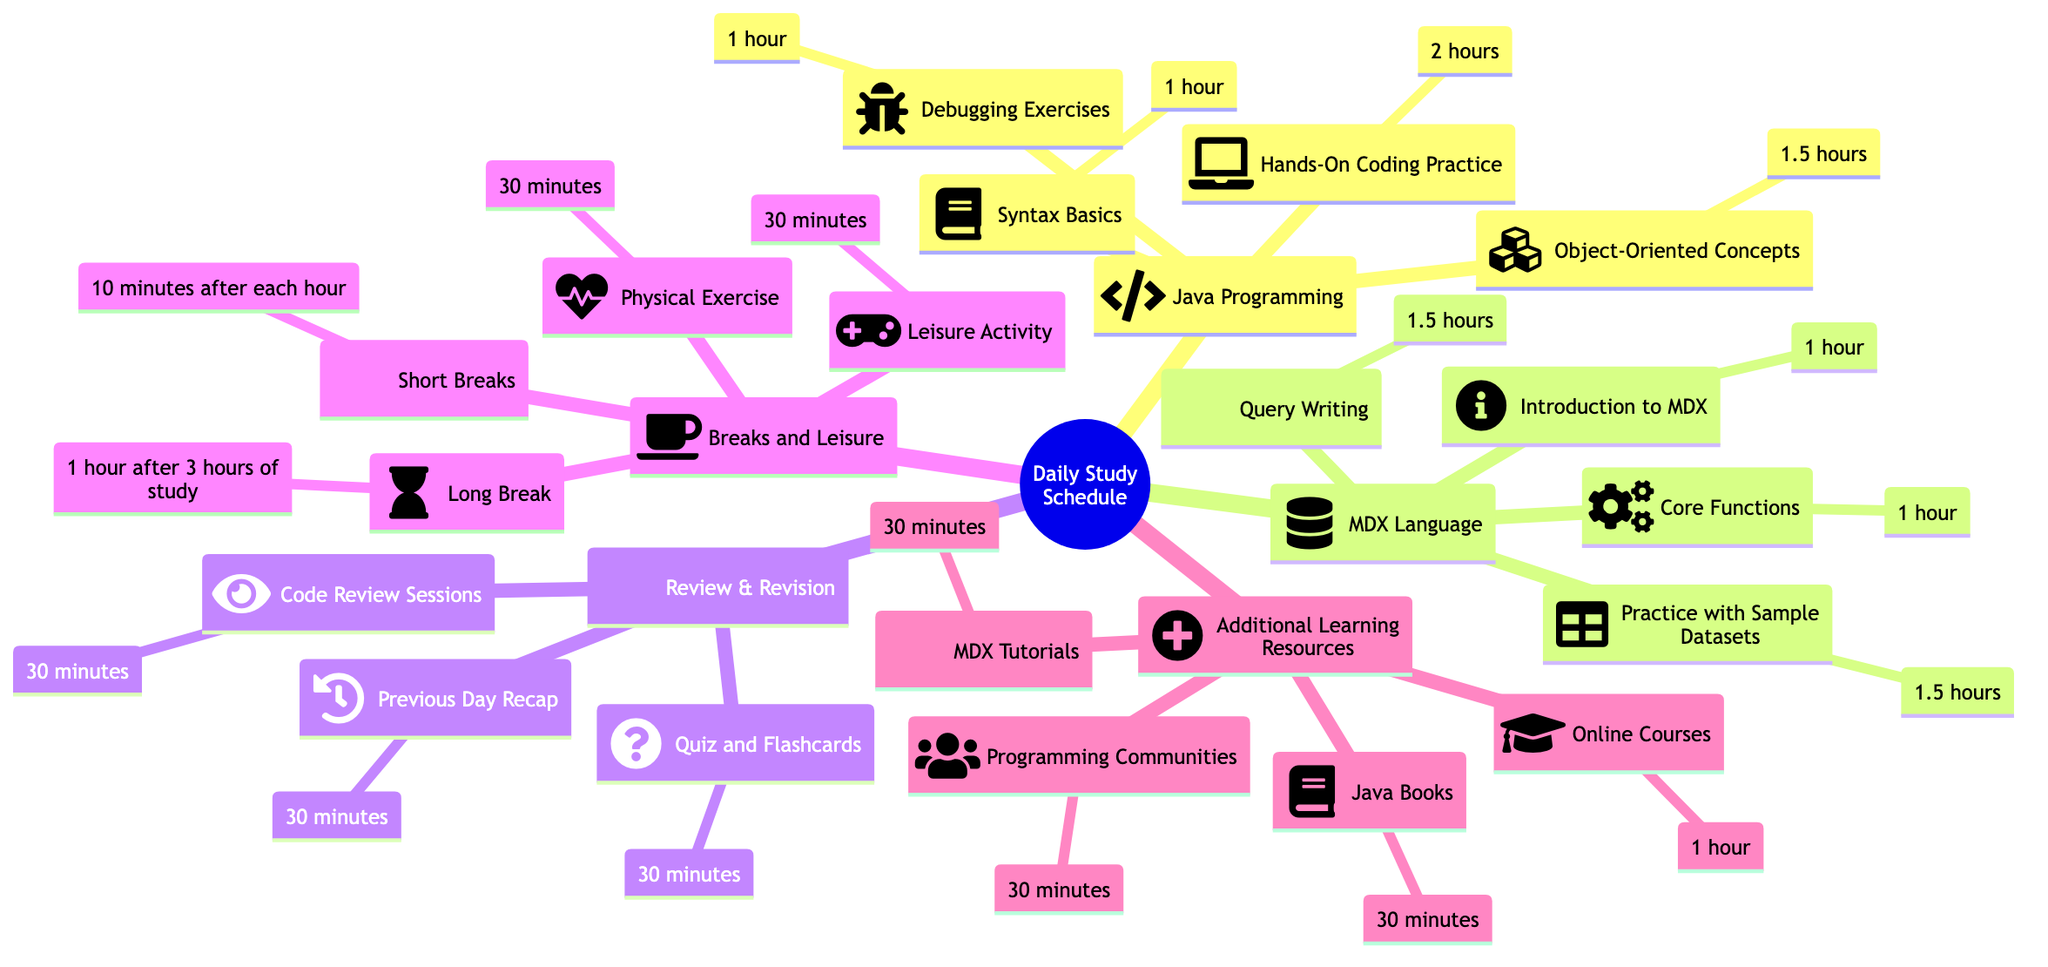What is the total time allocated for Java Programming study? To find the total time for Java Programming, I need to sum the durations of all the sub-nodes: 1 hour (Syntax Basics) + 1.5 hours (Object-Oriented Concepts) + 2 hours (Hands-On Coding Practice) + 1 hour (Debugging Exercises) = 5.5 hours.
Answer: 5.5 hours How many subjects are covered in the daily study schedule? Counting the main categories in the diagram, I see five: Java Programming, MDX Language, Review & Revision, Breaks and Leisure, and Additional Learning Resources. Thus, the total is 5.
Answer: 5 What is the duration of Core Functions in the MDX Language section? Looking at the MDX Language subsection in the diagram, I see that Core Functions is listed as having a duration of 1 hour.
Answer: 1 hour What is the combined duration of review activities? To calculate the combined duration of review activities, I add the times for Code Review Sessions (30 minutes) + Quiz and Flashcards (30 minutes) + Previous Day Recap (30 minutes), which gives 30 + 30 + 30 = 90 minutes, or 1.5 hours.
Answer: 1.5 hours Which section has the longest individual study duration? By comparing the durations listed in each section, Hands-On Coding Practice (2 hours) under Java Programming stands out as the longest duration when compared to other activities.
Answer: 2 hours How often should short breaks be taken according to the diagram? The diagram indicates short breaks should be taken for 10 minutes after each hour of study, making it a recurring action tied to study sessions.
Answer: 10 minutes after each hour What is the total time allocated for leisure activities? In the Breaks and Leisure section, the leisure activities include Leisure Activity (30 minutes) and Physical Exercise (30 minutes), giving a total of 30 + 30 = 60 minutes, or 1 hour.
Answer: 1 hour How many hours are allocated for sample dataset practice in the MDX Language section? The diagram specifies that Practice with Sample Datasets in the MDX Language section is allocated 1.5 hours, which is straightforward to identify directly from the MDX sub-nodes.
Answer: 1.5 hours 